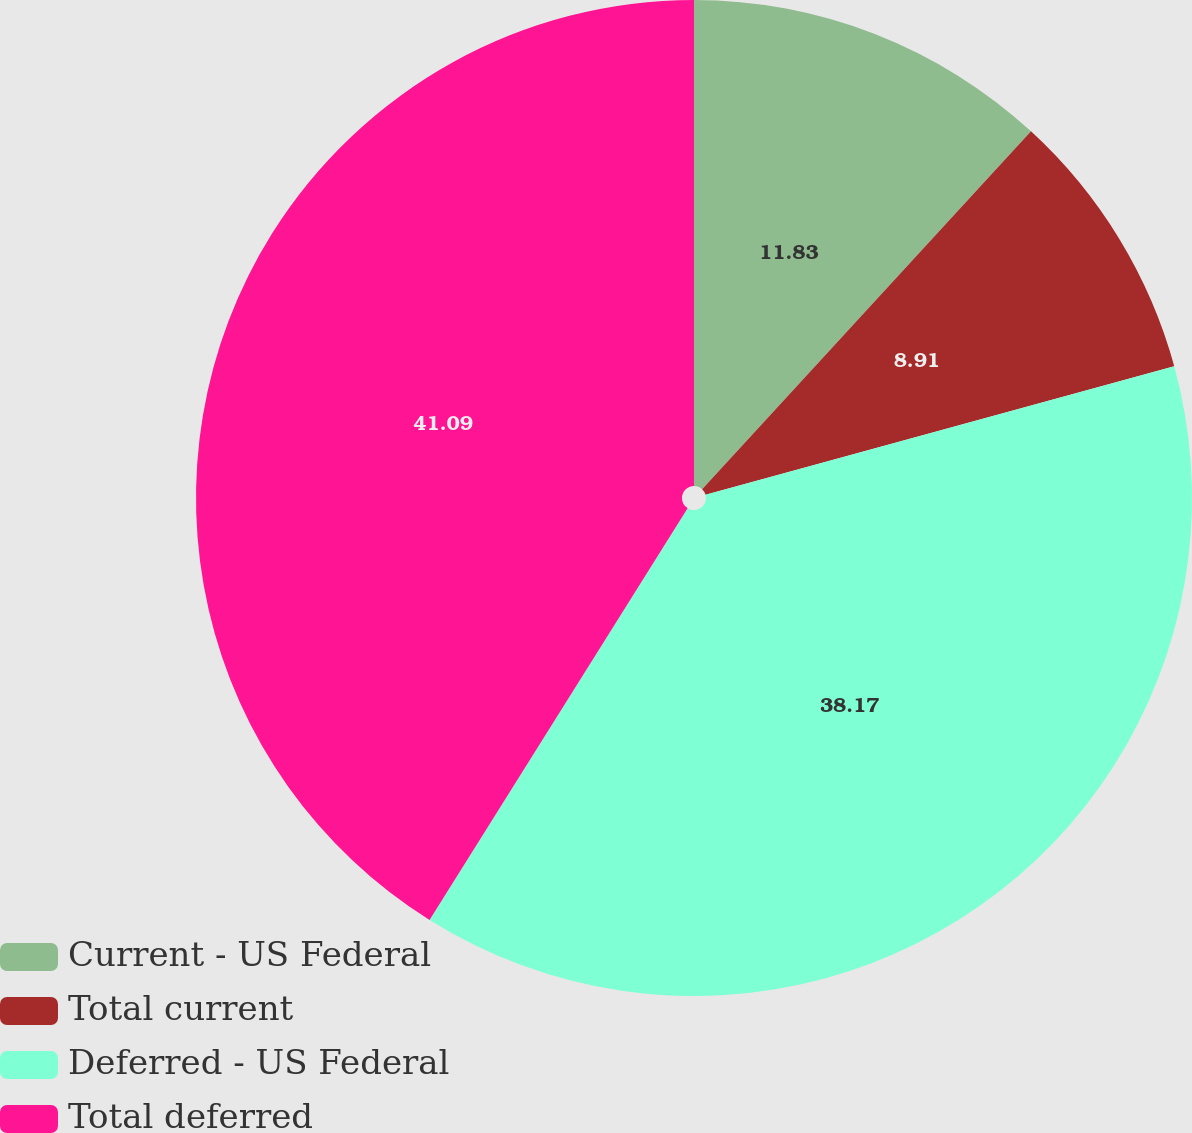<chart> <loc_0><loc_0><loc_500><loc_500><pie_chart><fcel>Current - US Federal<fcel>Total current<fcel>Deferred - US Federal<fcel>Total deferred<nl><fcel>11.83%<fcel>8.91%<fcel>38.17%<fcel>41.09%<nl></chart> 